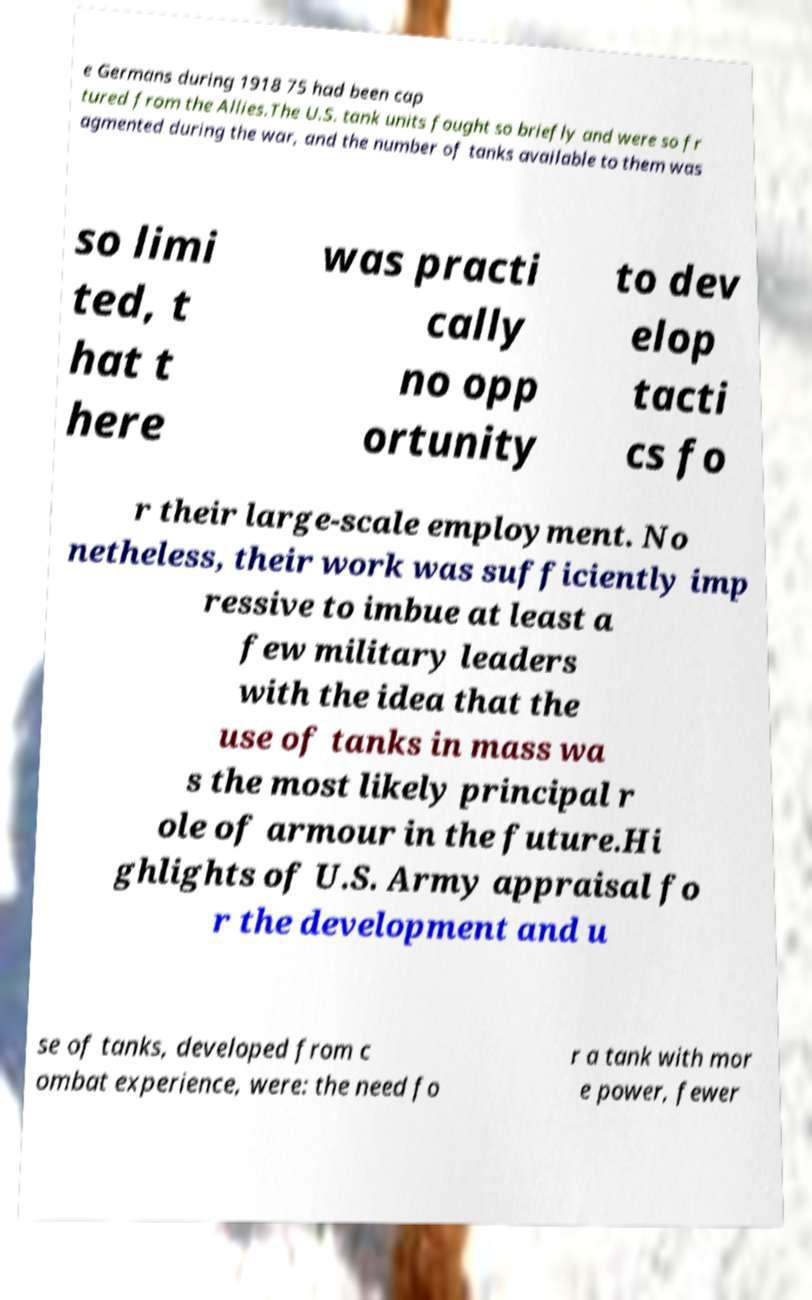For documentation purposes, I need the text within this image transcribed. Could you provide that? e Germans during 1918 75 had been cap tured from the Allies.The U.S. tank units fought so briefly and were so fr agmented during the war, and the number of tanks available to them was so limi ted, t hat t here was practi cally no opp ortunity to dev elop tacti cs fo r their large-scale employment. No netheless, their work was sufficiently imp ressive to imbue at least a few military leaders with the idea that the use of tanks in mass wa s the most likely principal r ole of armour in the future.Hi ghlights of U.S. Army appraisal fo r the development and u se of tanks, developed from c ombat experience, were: the need fo r a tank with mor e power, fewer 